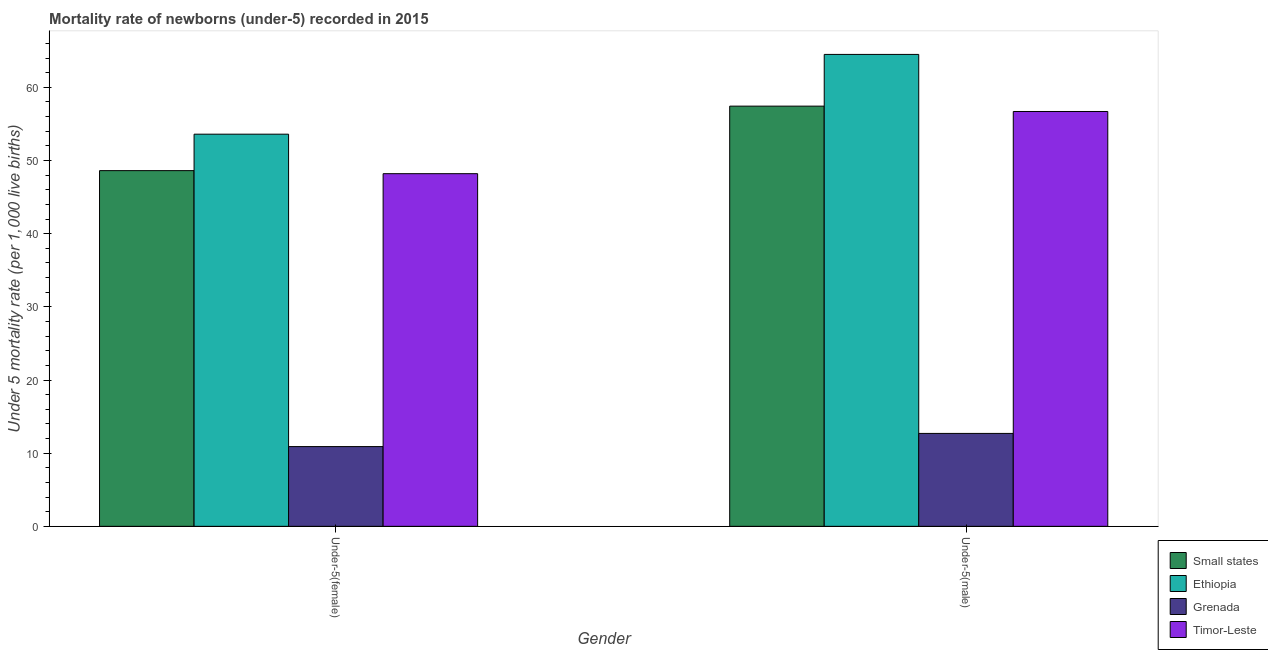How many groups of bars are there?
Your answer should be compact. 2. How many bars are there on the 2nd tick from the right?
Keep it short and to the point. 4. What is the label of the 1st group of bars from the left?
Offer a very short reply. Under-5(female). What is the under-5 female mortality rate in Timor-Leste?
Provide a short and direct response. 48.2. Across all countries, what is the maximum under-5 female mortality rate?
Your response must be concise. 53.6. In which country was the under-5 female mortality rate maximum?
Provide a short and direct response. Ethiopia. In which country was the under-5 male mortality rate minimum?
Your response must be concise. Grenada. What is the total under-5 male mortality rate in the graph?
Ensure brevity in your answer.  191.33. What is the difference between the under-5 female mortality rate in Grenada and that in Ethiopia?
Provide a succinct answer. -42.7. What is the difference between the under-5 female mortality rate in Ethiopia and the under-5 male mortality rate in Grenada?
Your response must be concise. 40.9. What is the average under-5 male mortality rate per country?
Provide a short and direct response. 47.83. What is the difference between the under-5 male mortality rate and under-5 female mortality rate in Ethiopia?
Offer a terse response. 10.9. What is the ratio of the under-5 male mortality rate in Grenada to that in Timor-Leste?
Keep it short and to the point. 0.22. What does the 4th bar from the left in Under-5(male) represents?
Provide a short and direct response. Timor-Leste. What does the 1st bar from the right in Under-5(female) represents?
Offer a terse response. Timor-Leste. How many bars are there?
Your answer should be compact. 8. Are all the bars in the graph horizontal?
Make the answer very short. No. Are the values on the major ticks of Y-axis written in scientific E-notation?
Keep it short and to the point. No. Does the graph contain any zero values?
Your response must be concise. No. Does the graph contain grids?
Make the answer very short. No. Where does the legend appear in the graph?
Offer a very short reply. Bottom right. How are the legend labels stacked?
Your answer should be very brief. Vertical. What is the title of the graph?
Offer a very short reply. Mortality rate of newborns (under-5) recorded in 2015. Does "Belarus" appear as one of the legend labels in the graph?
Provide a succinct answer. No. What is the label or title of the X-axis?
Give a very brief answer. Gender. What is the label or title of the Y-axis?
Make the answer very short. Under 5 mortality rate (per 1,0 live births). What is the Under 5 mortality rate (per 1,000 live births) of Small states in Under-5(female)?
Give a very brief answer. 48.62. What is the Under 5 mortality rate (per 1,000 live births) in Ethiopia in Under-5(female)?
Your response must be concise. 53.6. What is the Under 5 mortality rate (per 1,000 live births) of Timor-Leste in Under-5(female)?
Make the answer very short. 48.2. What is the Under 5 mortality rate (per 1,000 live births) in Small states in Under-5(male)?
Offer a terse response. 57.43. What is the Under 5 mortality rate (per 1,000 live births) of Ethiopia in Under-5(male)?
Make the answer very short. 64.5. What is the Under 5 mortality rate (per 1,000 live births) in Grenada in Under-5(male)?
Offer a terse response. 12.7. What is the Under 5 mortality rate (per 1,000 live births) of Timor-Leste in Under-5(male)?
Ensure brevity in your answer.  56.7. Across all Gender, what is the maximum Under 5 mortality rate (per 1,000 live births) in Small states?
Give a very brief answer. 57.43. Across all Gender, what is the maximum Under 5 mortality rate (per 1,000 live births) in Ethiopia?
Offer a terse response. 64.5. Across all Gender, what is the maximum Under 5 mortality rate (per 1,000 live births) of Timor-Leste?
Offer a very short reply. 56.7. Across all Gender, what is the minimum Under 5 mortality rate (per 1,000 live births) of Small states?
Ensure brevity in your answer.  48.62. Across all Gender, what is the minimum Under 5 mortality rate (per 1,000 live births) of Ethiopia?
Keep it short and to the point. 53.6. Across all Gender, what is the minimum Under 5 mortality rate (per 1,000 live births) of Grenada?
Keep it short and to the point. 10.9. Across all Gender, what is the minimum Under 5 mortality rate (per 1,000 live births) of Timor-Leste?
Make the answer very short. 48.2. What is the total Under 5 mortality rate (per 1,000 live births) in Small states in the graph?
Offer a terse response. 106.05. What is the total Under 5 mortality rate (per 1,000 live births) in Ethiopia in the graph?
Your answer should be compact. 118.1. What is the total Under 5 mortality rate (per 1,000 live births) in Grenada in the graph?
Your answer should be very brief. 23.6. What is the total Under 5 mortality rate (per 1,000 live births) of Timor-Leste in the graph?
Your answer should be very brief. 104.9. What is the difference between the Under 5 mortality rate (per 1,000 live births) in Small states in Under-5(female) and that in Under-5(male)?
Offer a very short reply. -8.81. What is the difference between the Under 5 mortality rate (per 1,000 live births) of Ethiopia in Under-5(female) and that in Under-5(male)?
Give a very brief answer. -10.9. What is the difference between the Under 5 mortality rate (per 1,000 live births) in Grenada in Under-5(female) and that in Under-5(male)?
Provide a short and direct response. -1.8. What is the difference between the Under 5 mortality rate (per 1,000 live births) in Small states in Under-5(female) and the Under 5 mortality rate (per 1,000 live births) in Ethiopia in Under-5(male)?
Ensure brevity in your answer.  -15.88. What is the difference between the Under 5 mortality rate (per 1,000 live births) of Small states in Under-5(female) and the Under 5 mortality rate (per 1,000 live births) of Grenada in Under-5(male)?
Offer a very short reply. 35.92. What is the difference between the Under 5 mortality rate (per 1,000 live births) in Small states in Under-5(female) and the Under 5 mortality rate (per 1,000 live births) in Timor-Leste in Under-5(male)?
Offer a terse response. -8.08. What is the difference between the Under 5 mortality rate (per 1,000 live births) in Ethiopia in Under-5(female) and the Under 5 mortality rate (per 1,000 live births) in Grenada in Under-5(male)?
Provide a succinct answer. 40.9. What is the difference between the Under 5 mortality rate (per 1,000 live births) of Ethiopia in Under-5(female) and the Under 5 mortality rate (per 1,000 live births) of Timor-Leste in Under-5(male)?
Keep it short and to the point. -3.1. What is the difference between the Under 5 mortality rate (per 1,000 live births) of Grenada in Under-5(female) and the Under 5 mortality rate (per 1,000 live births) of Timor-Leste in Under-5(male)?
Ensure brevity in your answer.  -45.8. What is the average Under 5 mortality rate (per 1,000 live births) of Small states per Gender?
Give a very brief answer. 53.02. What is the average Under 5 mortality rate (per 1,000 live births) of Ethiopia per Gender?
Your answer should be very brief. 59.05. What is the average Under 5 mortality rate (per 1,000 live births) in Grenada per Gender?
Provide a succinct answer. 11.8. What is the average Under 5 mortality rate (per 1,000 live births) in Timor-Leste per Gender?
Provide a succinct answer. 52.45. What is the difference between the Under 5 mortality rate (per 1,000 live births) of Small states and Under 5 mortality rate (per 1,000 live births) of Ethiopia in Under-5(female)?
Provide a short and direct response. -4.98. What is the difference between the Under 5 mortality rate (per 1,000 live births) of Small states and Under 5 mortality rate (per 1,000 live births) of Grenada in Under-5(female)?
Keep it short and to the point. 37.72. What is the difference between the Under 5 mortality rate (per 1,000 live births) in Small states and Under 5 mortality rate (per 1,000 live births) in Timor-Leste in Under-5(female)?
Your answer should be compact. 0.42. What is the difference between the Under 5 mortality rate (per 1,000 live births) of Ethiopia and Under 5 mortality rate (per 1,000 live births) of Grenada in Under-5(female)?
Make the answer very short. 42.7. What is the difference between the Under 5 mortality rate (per 1,000 live births) of Grenada and Under 5 mortality rate (per 1,000 live births) of Timor-Leste in Under-5(female)?
Make the answer very short. -37.3. What is the difference between the Under 5 mortality rate (per 1,000 live births) of Small states and Under 5 mortality rate (per 1,000 live births) of Ethiopia in Under-5(male)?
Your response must be concise. -7.07. What is the difference between the Under 5 mortality rate (per 1,000 live births) in Small states and Under 5 mortality rate (per 1,000 live births) in Grenada in Under-5(male)?
Provide a succinct answer. 44.73. What is the difference between the Under 5 mortality rate (per 1,000 live births) in Small states and Under 5 mortality rate (per 1,000 live births) in Timor-Leste in Under-5(male)?
Give a very brief answer. 0.73. What is the difference between the Under 5 mortality rate (per 1,000 live births) of Ethiopia and Under 5 mortality rate (per 1,000 live births) of Grenada in Under-5(male)?
Your answer should be very brief. 51.8. What is the difference between the Under 5 mortality rate (per 1,000 live births) of Ethiopia and Under 5 mortality rate (per 1,000 live births) of Timor-Leste in Under-5(male)?
Your response must be concise. 7.8. What is the difference between the Under 5 mortality rate (per 1,000 live births) in Grenada and Under 5 mortality rate (per 1,000 live births) in Timor-Leste in Under-5(male)?
Keep it short and to the point. -44. What is the ratio of the Under 5 mortality rate (per 1,000 live births) of Small states in Under-5(female) to that in Under-5(male)?
Offer a terse response. 0.85. What is the ratio of the Under 5 mortality rate (per 1,000 live births) of Ethiopia in Under-5(female) to that in Under-5(male)?
Keep it short and to the point. 0.83. What is the ratio of the Under 5 mortality rate (per 1,000 live births) in Grenada in Under-5(female) to that in Under-5(male)?
Provide a short and direct response. 0.86. What is the ratio of the Under 5 mortality rate (per 1,000 live births) in Timor-Leste in Under-5(female) to that in Under-5(male)?
Your answer should be very brief. 0.85. What is the difference between the highest and the second highest Under 5 mortality rate (per 1,000 live births) in Small states?
Your answer should be compact. 8.81. What is the difference between the highest and the second highest Under 5 mortality rate (per 1,000 live births) in Ethiopia?
Offer a terse response. 10.9. What is the difference between the highest and the lowest Under 5 mortality rate (per 1,000 live births) in Small states?
Offer a very short reply. 8.81. What is the difference between the highest and the lowest Under 5 mortality rate (per 1,000 live births) in Ethiopia?
Your answer should be compact. 10.9. What is the difference between the highest and the lowest Under 5 mortality rate (per 1,000 live births) in Timor-Leste?
Your answer should be very brief. 8.5. 